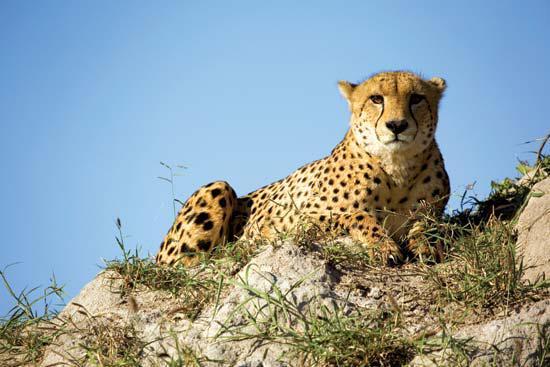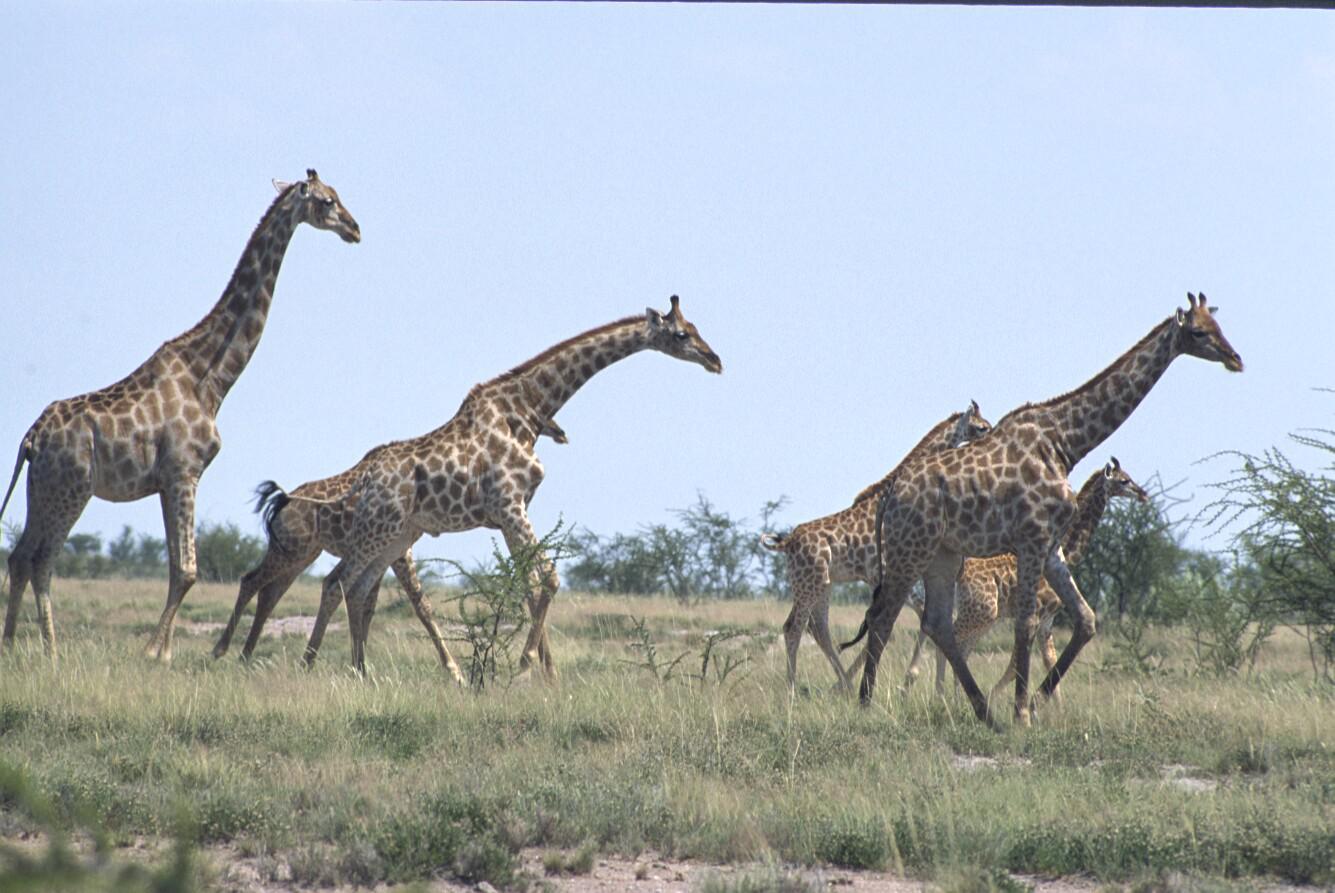The first image is the image on the left, the second image is the image on the right. Given the left and right images, does the statement "There are at most 3 cheetahs in the image pair" hold true? Answer yes or no. Yes. 